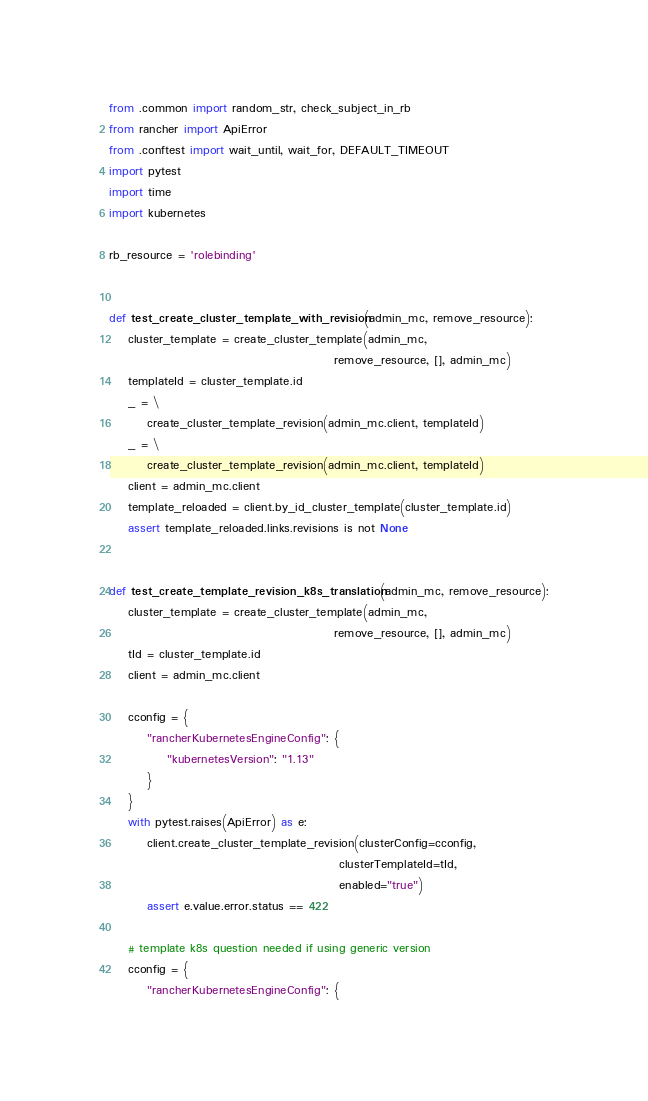<code> <loc_0><loc_0><loc_500><loc_500><_Python_>from .common import random_str, check_subject_in_rb
from rancher import ApiError
from .conftest import wait_until, wait_for, DEFAULT_TIMEOUT
import pytest
import time
import kubernetes

rb_resource = 'rolebinding'


def test_create_cluster_template_with_revision(admin_mc, remove_resource):
    cluster_template = create_cluster_template(admin_mc,
                                               remove_resource, [], admin_mc)
    templateId = cluster_template.id
    _ = \
        create_cluster_template_revision(admin_mc.client, templateId)
    _ = \
        create_cluster_template_revision(admin_mc.client, templateId)
    client = admin_mc.client
    template_reloaded = client.by_id_cluster_template(cluster_template.id)
    assert template_reloaded.links.revisions is not None


def test_create_template_revision_k8s_translation(admin_mc, remove_resource):
    cluster_template = create_cluster_template(admin_mc,
                                               remove_resource, [], admin_mc)
    tId = cluster_template.id
    client = admin_mc.client

    cconfig = {
        "rancherKubernetesEngineConfig": {
            "kubernetesVersion": "1.13"
        }
    }
    with pytest.raises(ApiError) as e:
        client.create_cluster_template_revision(clusterConfig=cconfig,
                                                clusterTemplateId=tId,
                                                enabled="true")
        assert e.value.error.status == 422

    # template k8s question needed if using generic version
    cconfig = {
        "rancherKubernetesEngineConfig": {</code> 